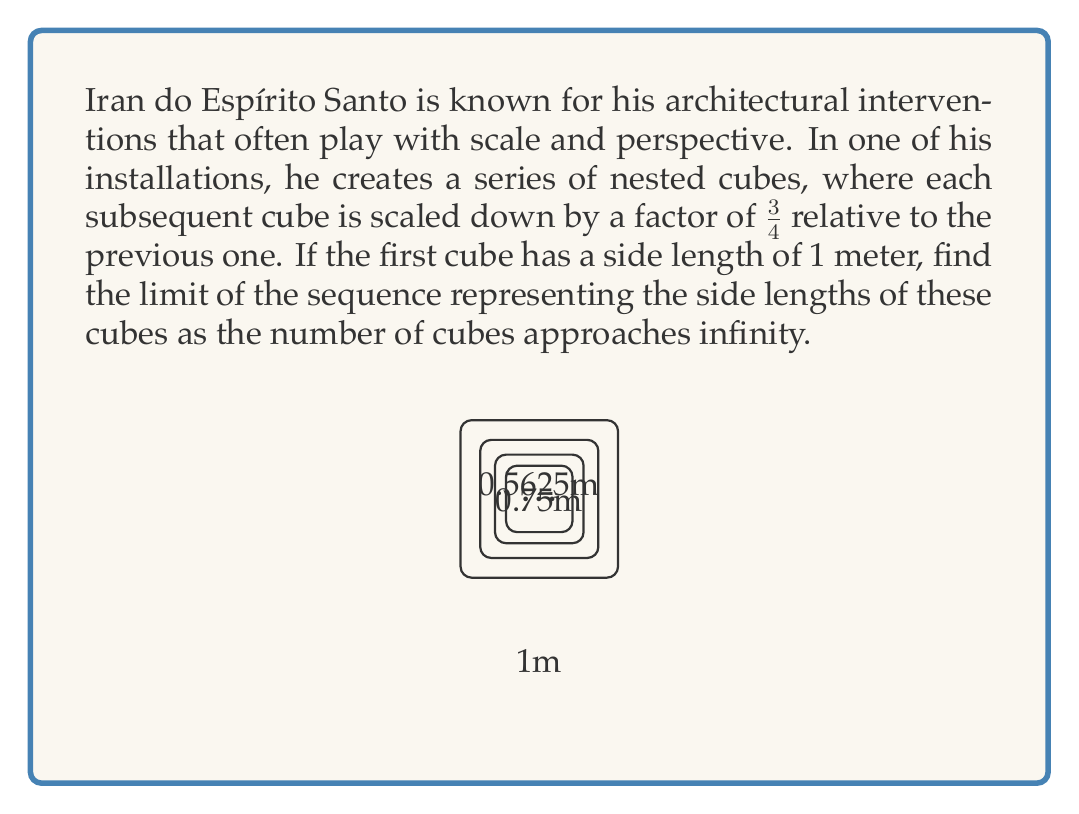Solve this math problem. Let's approach this step-by-step:

1) We're dealing with a geometric sequence where each term is $\frac{3}{4}$ of the previous term.

2) Let's define the sequence $a_n$ where $a_n$ represents the side length of the $n$-th cube:

   $a_1 = 1$
   $a_2 = 1 \cdot \frac{3}{4} = \frac{3}{4}$
   $a_3 = \frac{3}{4} \cdot \frac{3}{4} = (\frac{3}{4})^2$
   $a_4 = (\frac{3}{4})^2 \cdot \frac{3}{4} = (\frac{3}{4})^3$

3) We can see that the general term of this sequence is:

   $a_n = (\frac{3}{4})^{n-1}$

4) To find the limit of this sequence as $n$ approaches infinity, we need to evaluate:

   $\lim_{n \to \infty} a_n = \lim_{n \to \infty} (\frac{3}{4})^{n-1}$

5) We know that for any $r$ where $|r| < 1$, $\lim_{n \to \infty} r^n = 0$

6) In our case, $|\frac{3}{4}| = \frac{3}{4} < 1$, so:

   $\lim_{n \to \infty} (\frac{3}{4})^{n-1} = 0$

Therefore, as the number of cubes approaches infinity, the side length of the cubes approaches 0.
Answer: $0$ 